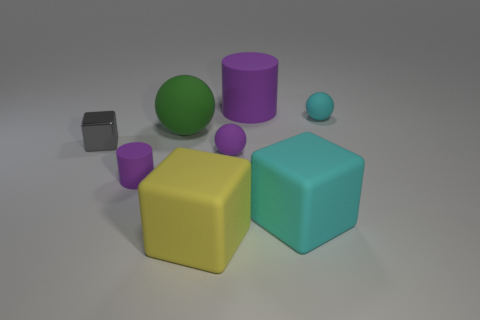How many purple cylinders must be subtracted to get 1 purple cylinders? 1 Subtract all cyan balls. How many balls are left? 2 Add 1 big red cubes. How many objects exist? 9 Subtract 3 cubes. How many cubes are left? 0 Subtract all yellow rubber things. Subtract all yellow rubber things. How many objects are left? 6 Add 3 large matte cubes. How many large matte cubes are left? 5 Add 5 tiny gray objects. How many tiny gray objects exist? 6 Subtract 0 brown blocks. How many objects are left? 8 Subtract all cylinders. How many objects are left? 6 Subtract all brown cylinders. Subtract all blue balls. How many cylinders are left? 2 